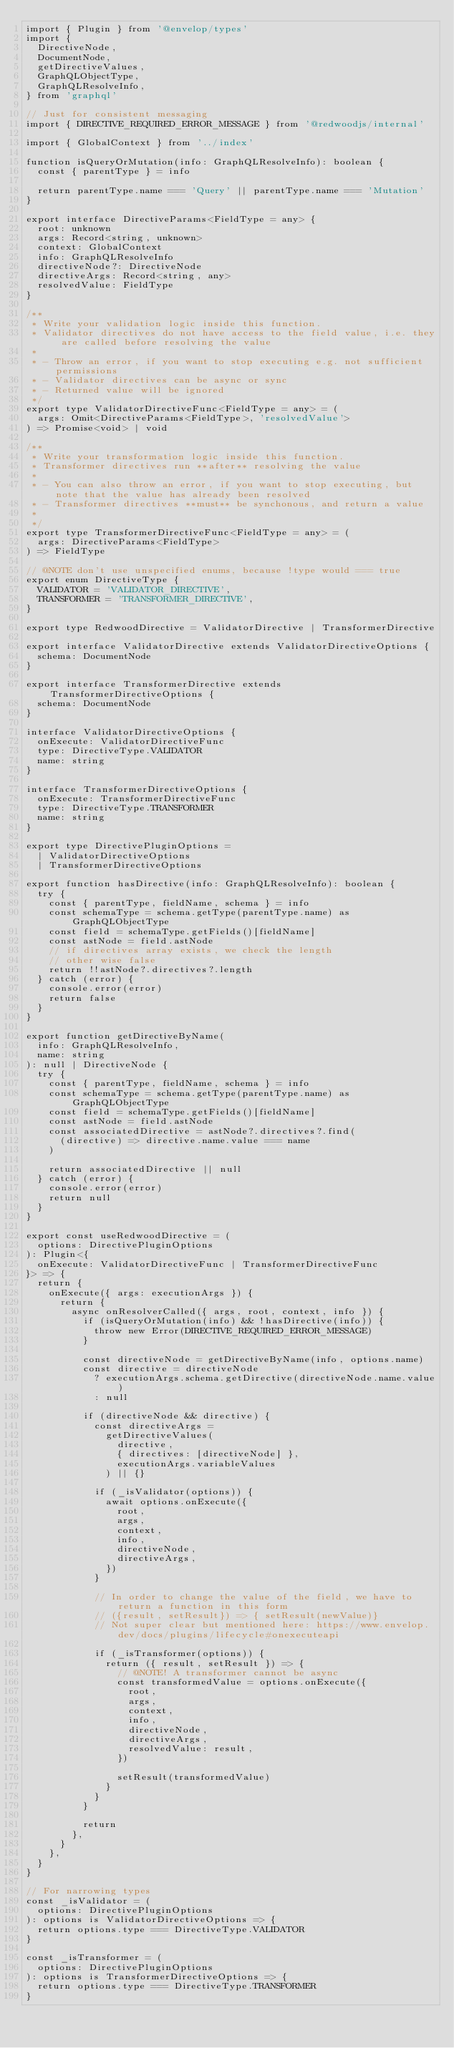Convert code to text. <code><loc_0><loc_0><loc_500><loc_500><_TypeScript_>import { Plugin } from '@envelop/types'
import {
  DirectiveNode,
  DocumentNode,
  getDirectiveValues,
  GraphQLObjectType,
  GraphQLResolveInfo,
} from 'graphql'

// Just for consistent messaging
import { DIRECTIVE_REQUIRED_ERROR_MESSAGE } from '@redwoodjs/internal'

import { GlobalContext } from '../index'

function isQueryOrMutation(info: GraphQLResolveInfo): boolean {
  const { parentType } = info

  return parentType.name === 'Query' || parentType.name === 'Mutation'
}

export interface DirectiveParams<FieldType = any> {
  root: unknown
  args: Record<string, unknown>
  context: GlobalContext
  info: GraphQLResolveInfo
  directiveNode?: DirectiveNode
  directiveArgs: Record<string, any>
  resolvedValue: FieldType
}

/**
 * Write your validation logic inside this function.
 * Validator directives do not have access to the field value, i.e. they are called before resolving the value
 *
 * - Throw an error, if you want to stop executing e.g. not sufficient permissions
 * - Validator directives can be async or sync
 * - Returned value will be ignored
 */
export type ValidatorDirectiveFunc<FieldType = any> = (
  args: Omit<DirectiveParams<FieldType>, 'resolvedValue'>
) => Promise<void> | void

/**
 * Write your transformation logic inside this function.
 * Transformer directives run **after** resolving the value
 *
 * - You can also throw an error, if you want to stop executing, but note that the value has already been resolved
 * - Transformer directives **must** be synchonous, and return a value
 *
 */
export type TransformerDirectiveFunc<FieldType = any> = (
  args: DirectiveParams<FieldType>
) => FieldType

// @NOTE don't use unspecified enums, because !type would === true
export enum DirectiveType {
  VALIDATOR = 'VALIDATOR_DIRECTIVE',
  TRANSFORMER = 'TRANSFORMER_DIRECTIVE',
}

export type RedwoodDirective = ValidatorDirective | TransformerDirective

export interface ValidatorDirective extends ValidatorDirectiveOptions {
  schema: DocumentNode
}

export interface TransformerDirective extends TransformerDirectiveOptions {
  schema: DocumentNode
}

interface ValidatorDirectiveOptions {
  onExecute: ValidatorDirectiveFunc
  type: DirectiveType.VALIDATOR
  name: string
}

interface TransformerDirectiveOptions {
  onExecute: TransformerDirectiveFunc
  type: DirectiveType.TRANSFORMER
  name: string
}

export type DirectivePluginOptions =
  | ValidatorDirectiveOptions
  | TransformerDirectiveOptions

export function hasDirective(info: GraphQLResolveInfo): boolean {
  try {
    const { parentType, fieldName, schema } = info
    const schemaType = schema.getType(parentType.name) as GraphQLObjectType
    const field = schemaType.getFields()[fieldName]
    const astNode = field.astNode
    // if directives array exists, we check the length
    // other wise false
    return !!astNode?.directives?.length
  } catch (error) {
    console.error(error)
    return false
  }
}

export function getDirectiveByName(
  info: GraphQLResolveInfo,
  name: string
): null | DirectiveNode {
  try {
    const { parentType, fieldName, schema } = info
    const schemaType = schema.getType(parentType.name) as GraphQLObjectType
    const field = schemaType.getFields()[fieldName]
    const astNode = field.astNode
    const associatedDirective = astNode?.directives?.find(
      (directive) => directive.name.value === name
    )

    return associatedDirective || null
  } catch (error) {
    console.error(error)
    return null
  }
}

export const useRedwoodDirective = (
  options: DirectivePluginOptions
): Plugin<{
  onExecute: ValidatorDirectiveFunc | TransformerDirectiveFunc
}> => {
  return {
    onExecute({ args: executionArgs }) {
      return {
        async onResolverCalled({ args, root, context, info }) {
          if (isQueryOrMutation(info) && !hasDirective(info)) {
            throw new Error(DIRECTIVE_REQUIRED_ERROR_MESSAGE)
          }

          const directiveNode = getDirectiveByName(info, options.name)
          const directive = directiveNode
            ? executionArgs.schema.getDirective(directiveNode.name.value)
            : null

          if (directiveNode && directive) {
            const directiveArgs =
              getDirectiveValues(
                directive,
                { directives: [directiveNode] },
                executionArgs.variableValues
              ) || {}

            if (_isValidator(options)) {
              await options.onExecute({
                root,
                args,
                context,
                info,
                directiveNode,
                directiveArgs,
              })
            }

            // In order to change the value of the field, we have to return a function in this form
            // ({result, setResult}) => { setResult(newValue)}
            // Not super clear but mentioned here: https://www.envelop.dev/docs/plugins/lifecycle#onexecuteapi

            if (_isTransformer(options)) {
              return ({ result, setResult }) => {
                // @NOTE! A transformer cannot be async
                const transformedValue = options.onExecute({
                  root,
                  args,
                  context,
                  info,
                  directiveNode,
                  directiveArgs,
                  resolvedValue: result,
                })

                setResult(transformedValue)
              }
            }
          }

          return
        },
      }
    },
  }
}

// For narrowing types
const _isValidator = (
  options: DirectivePluginOptions
): options is ValidatorDirectiveOptions => {
  return options.type === DirectiveType.VALIDATOR
}

const _isTransformer = (
  options: DirectivePluginOptions
): options is TransformerDirectiveOptions => {
  return options.type === DirectiveType.TRANSFORMER
}
</code> 